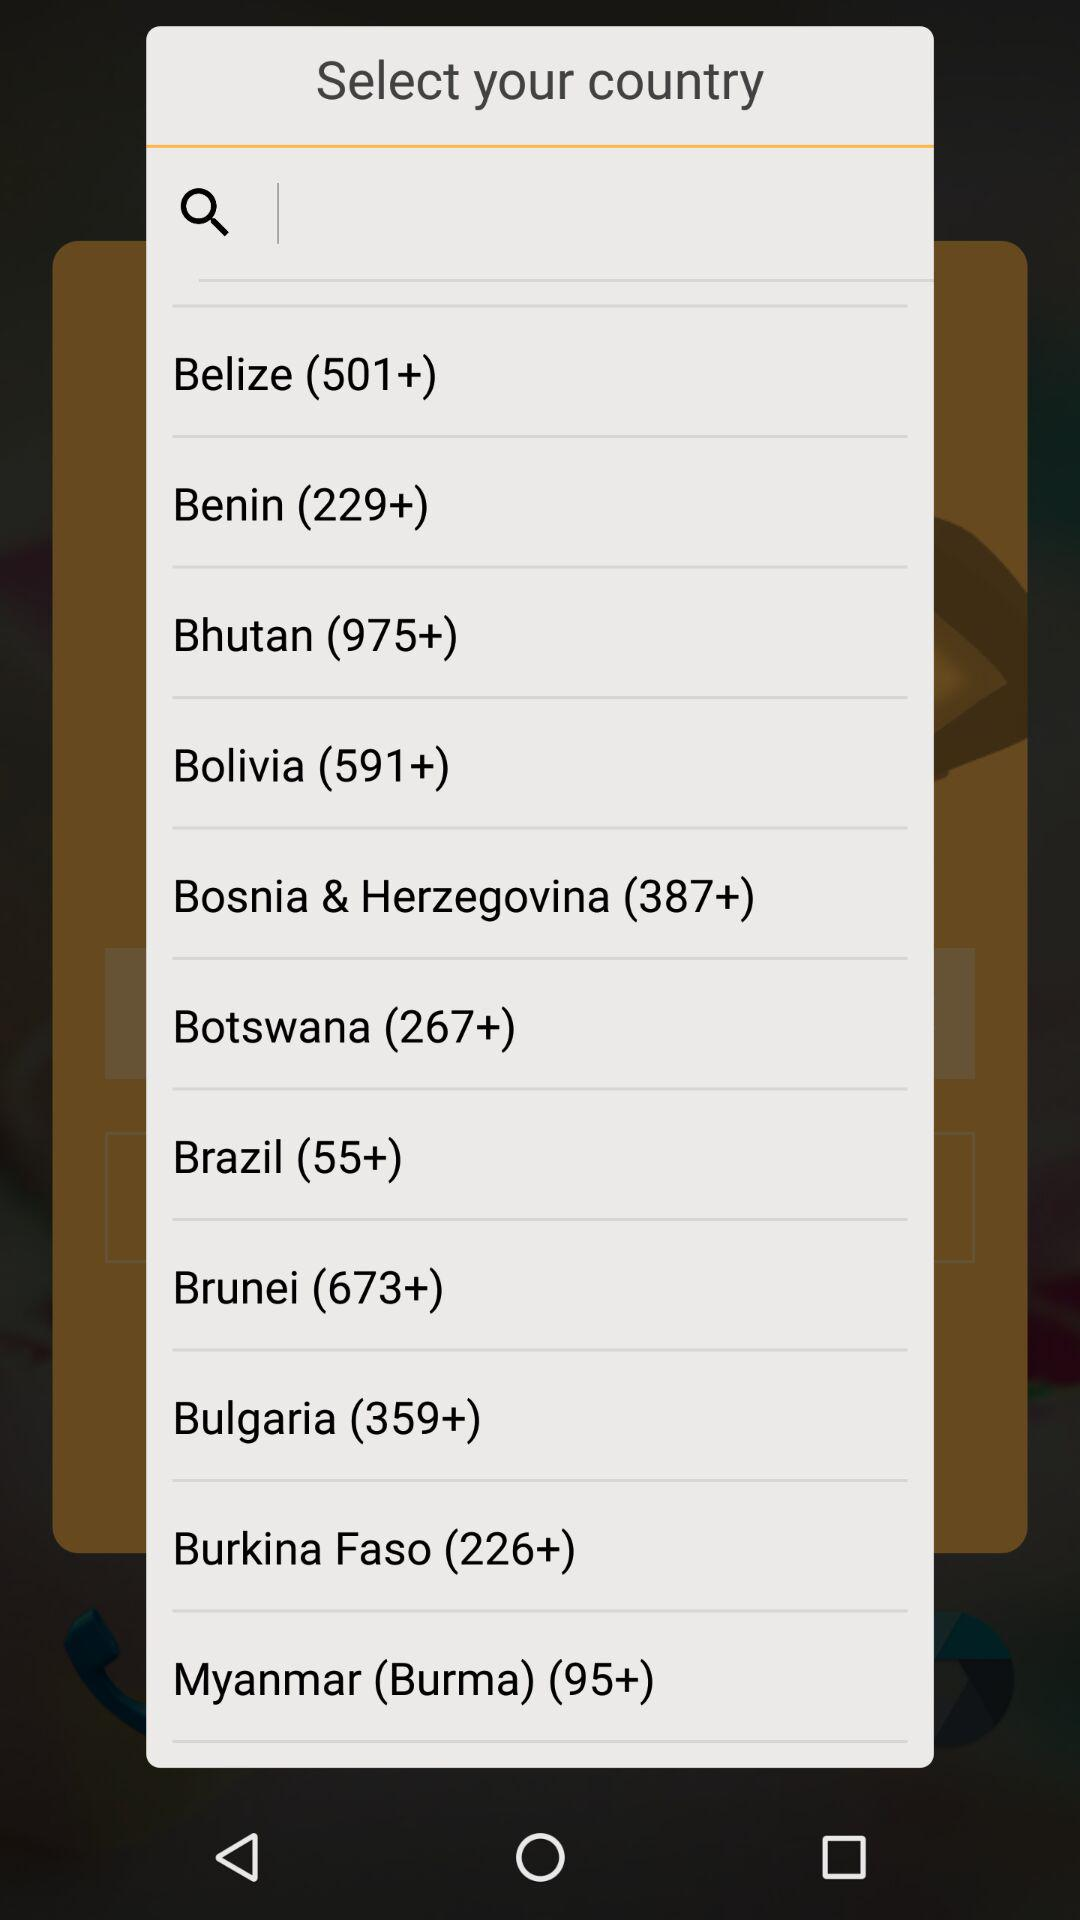What is the country code for Brazil? The country code for Brazil is (55+). 